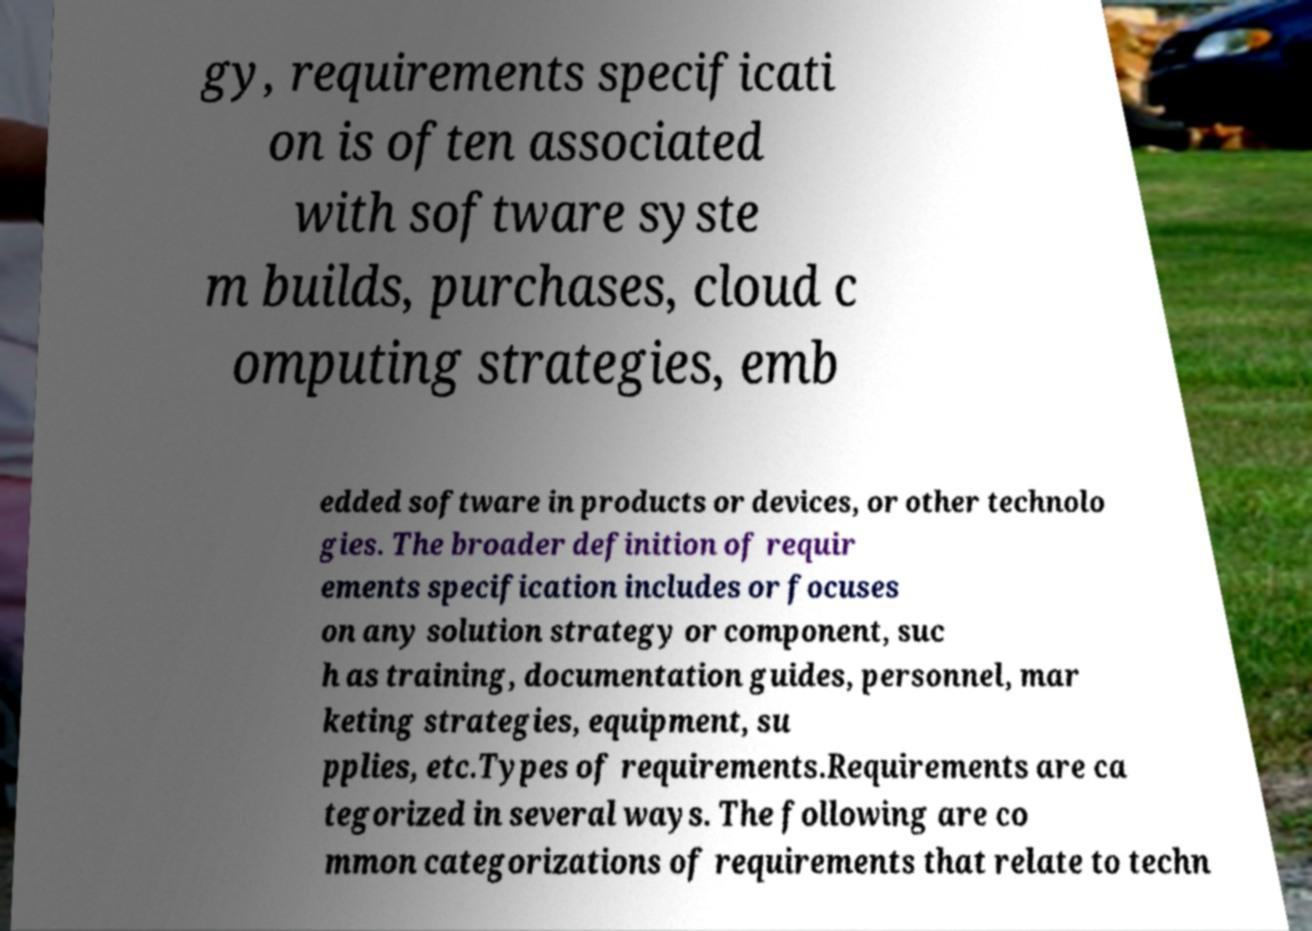For documentation purposes, I need the text within this image transcribed. Could you provide that? gy, requirements specificati on is often associated with software syste m builds, purchases, cloud c omputing strategies, emb edded software in products or devices, or other technolo gies. The broader definition of requir ements specification includes or focuses on any solution strategy or component, suc h as training, documentation guides, personnel, mar keting strategies, equipment, su pplies, etc.Types of requirements.Requirements are ca tegorized in several ways. The following are co mmon categorizations of requirements that relate to techn 